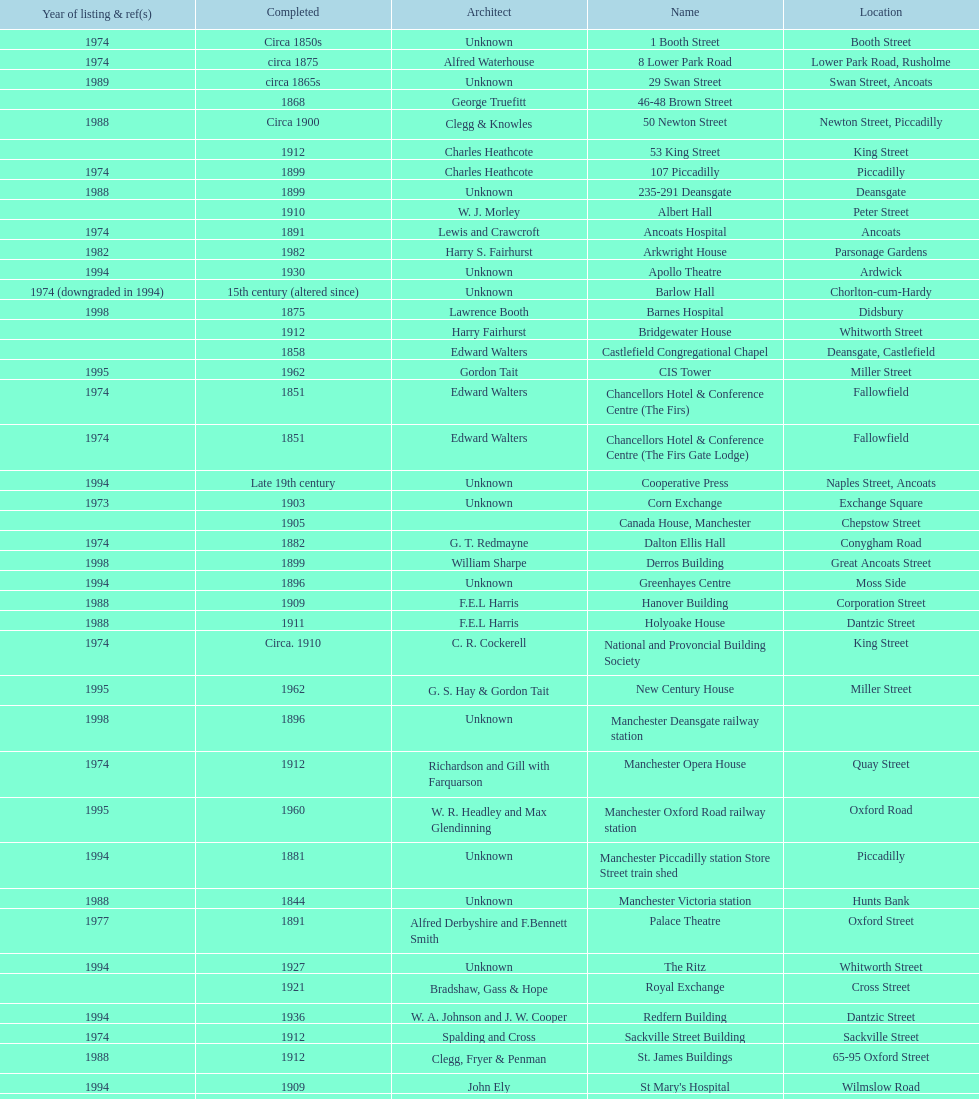Could you parse the entire table as a dict? {'header': ['Year of listing & ref(s)', 'Completed', 'Architect', 'Name', 'Location'], 'rows': [['1974', 'Circa 1850s', 'Unknown', '1 Booth Street', 'Booth Street'], ['1974', 'circa 1875', 'Alfred Waterhouse', '8 Lower Park Road', 'Lower Park Road, Rusholme'], ['1989', 'circa 1865s', 'Unknown', '29 Swan Street', 'Swan Street, Ancoats'], ['', '1868', 'George Truefitt', '46-48 Brown Street', ''], ['1988', 'Circa 1900', 'Clegg & Knowles', '50 Newton Street', 'Newton Street, Piccadilly'], ['', '1912', 'Charles Heathcote', '53 King Street', 'King Street'], ['1974', '1899', 'Charles Heathcote', '107 Piccadilly', 'Piccadilly'], ['1988', '1899', 'Unknown', '235-291 Deansgate', 'Deansgate'], ['', '1910', 'W. J. Morley', 'Albert Hall', 'Peter Street'], ['1974', '1891', 'Lewis and Crawcroft', 'Ancoats Hospital', 'Ancoats'], ['1982', '1982', 'Harry S. Fairhurst', 'Arkwright House', 'Parsonage Gardens'], ['1994', '1930', 'Unknown', 'Apollo Theatre', 'Ardwick'], ['1974 (downgraded in 1994)', '15th century (altered since)', 'Unknown', 'Barlow Hall', 'Chorlton-cum-Hardy'], ['1998', '1875', 'Lawrence Booth', 'Barnes Hospital', 'Didsbury'], ['', '1912', 'Harry Fairhurst', 'Bridgewater House', 'Whitworth Street'], ['', '1858', 'Edward Walters', 'Castlefield Congregational Chapel', 'Deansgate, Castlefield'], ['1995', '1962', 'Gordon Tait', 'CIS Tower', 'Miller Street'], ['1974', '1851', 'Edward Walters', 'Chancellors Hotel & Conference Centre (The Firs)', 'Fallowfield'], ['1974', '1851', 'Edward Walters', 'Chancellors Hotel & Conference Centre (The Firs Gate Lodge)', 'Fallowfield'], ['1994', 'Late 19th century', 'Unknown', 'Cooperative Press', 'Naples Street, Ancoats'], ['1973', '1903', 'Unknown', 'Corn Exchange', 'Exchange Square'], ['', '1905', '', 'Canada House, Manchester', 'Chepstow Street'], ['1974', '1882', 'G. T. Redmayne', 'Dalton Ellis Hall', 'Conygham Road'], ['1998', '1899', 'William Sharpe', 'Derros Building', 'Great Ancoats Street'], ['1994', '1896', 'Unknown', 'Greenhayes Centre', 'Moss Side'], ['1988', '1909', 'F.E.L Harris', 'Hanover Building', 'Corporation Street'], ['1988', '1911', 'F.E.L Harris', 'Holyoake House', 'Dantzic Street'], ['1974', 'Circa. 1910', 'C. R. Cockerell', 'National and Provoncial Building Society', 'King Street'], ['1995', '1962', 'G. S. Hay & Gordon Tait', 'New Century House', 'Miller Street'], ['1998', '1896', 'Unknown', 'Manchester Deansgate railway station', ''], ['1974', '1912', 'Richardson and Gill with Farquarson', 'Manchester Opera House', 'Quay Street'], ['1995', '1960', 'W. R. Headley and Max Glendinning', 'Manchester Oxford Road railway station', 'Oxford Road'], ['1994', '1881', 'Unknown', 'Manchester Piccadilly station Store Street train shed', 'Piccadilly'], ['1988', '1844', 'Unknown', 'Manchester Victoria station', 'Hunts Bank'], ['1977', '1891', 'Alfred Derbyshire and F.Bennett Smith', 'Palace Theatre', 'Oxford Street'], ['1994', '1927', 'Unknown', 'The Ritz', 'Whitworth Street'], ['', '1921', 'Bradshaw, Gass & Hope', 'Royal Exchange', 'Cross Street'], ['1994', '1936', 'W. A. Johnson and J. W. Cooper', 'Redfern Building', 'Dantzic Street'], ['1974', '1912', 'Spalding and Cross', 'Sackville Street Building', 'Sackville Street'], ['1988', '1912', 'Clegg, Fryer & Penman', 'St. James Buildings', '65-95 Oxford Street'], ['1994', '1909', 'John Ely', "St Mary's Hospital", 'Wilmslow Road'], ['2010', '1919', 'Percy Scott Worthington', 'Samuel Alexander Building', 'Oxford Road'], ['1982', '1927', 'Harry S. Fairhurst', 'Ship Canal House', 'King Street'], ['1973', '1857', 'Unknown', 'Smithfield Market Hall', 'Swan Street, Ancoats'], ['1974', '1868', 'Alfred Waterhouse', 'Strangeways Gaol Gatehouse', 'Sherborne Street'], ['1974', '1868', 'Alfred Waterhouse', 'Strangeways Prison ventilation and watch tower', 'Sherborne Street'], ['1974', '1845', 'Irwin and Chester', 'Theatre Royal', 'Peter Street'], ['1999', '1960', 'L. C. Howitt', 'Toast Rack', 'Fallowfield'], ['1952', 'Mid-16th century', 'Unknown', 'The Old Wellington Inn', 'Shambles Square'], ['1974', 'Circa 1840s', 'Unknown', 'Whitworth Park Mansions', 'Whitworth Park']]} What is the difference, in years, between the completion dates of 53 king street and castlefield congregational chapel? 54 years. 